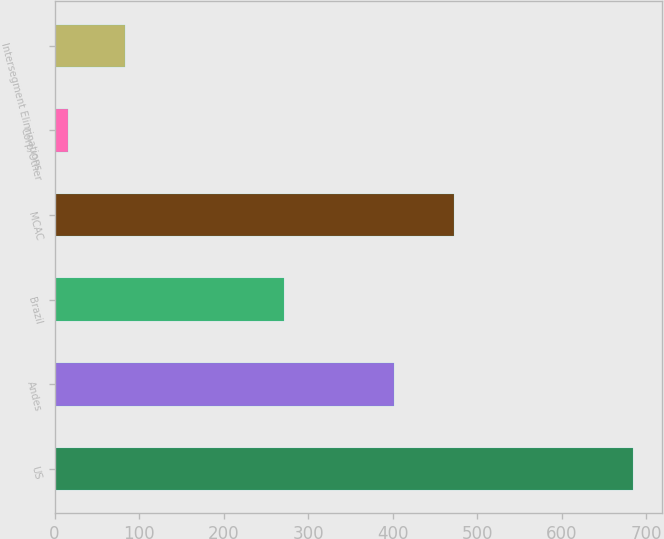<chart> <loc_0><loc_0><loc_500><loc_500><bar_chart><fcel>US<fcel>Andes<fcel>Brazil<fcel>MCAC<fcel>Corp/Other<fcel>Intersegment Eliminations<nl><fcel>684<fcel>402<fcel>271<fcel>472<fcel>16<fcel>82.8<nl></chart> 